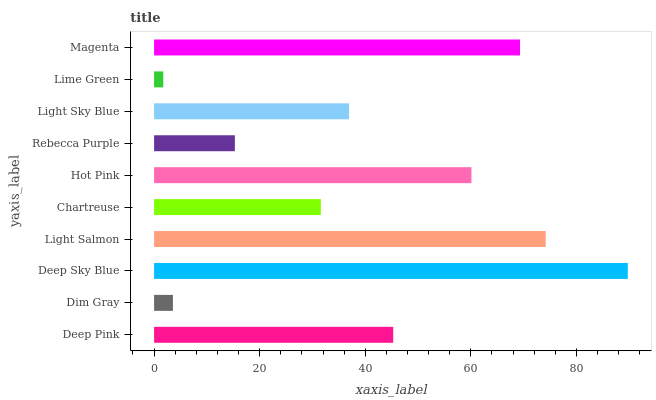Is Lime Green the minimum?
Answer yes or no. Yes. Is Deep Sky Blue the maximum?
Answer yes or no. Yes. Is Dim Gray the minimum?
Answer yes or no. No. Is Dim Gray the maximum?
Answer yes or no. No. Is Deep Pink greater than Dim Gray?
Answer yes or no. Yes. Is Dim Gray less than Deep Pink?
Answer yes or no. Yes. Is Dim Gray greater than Deep Pink?
Answer yes or no. No. Is Deep Pink less than Dim Gray?
Answer yes or no. No. Is Deep Pink the high median?
Answer yes or no. Yes. Is Light Sky Blue the low median?
Answer yes or no. Yes. Is Deep Sky Blue the high median?
Answer yes or no. No. Is Rebecca Purple the low median?
Answer yes or no. No. 